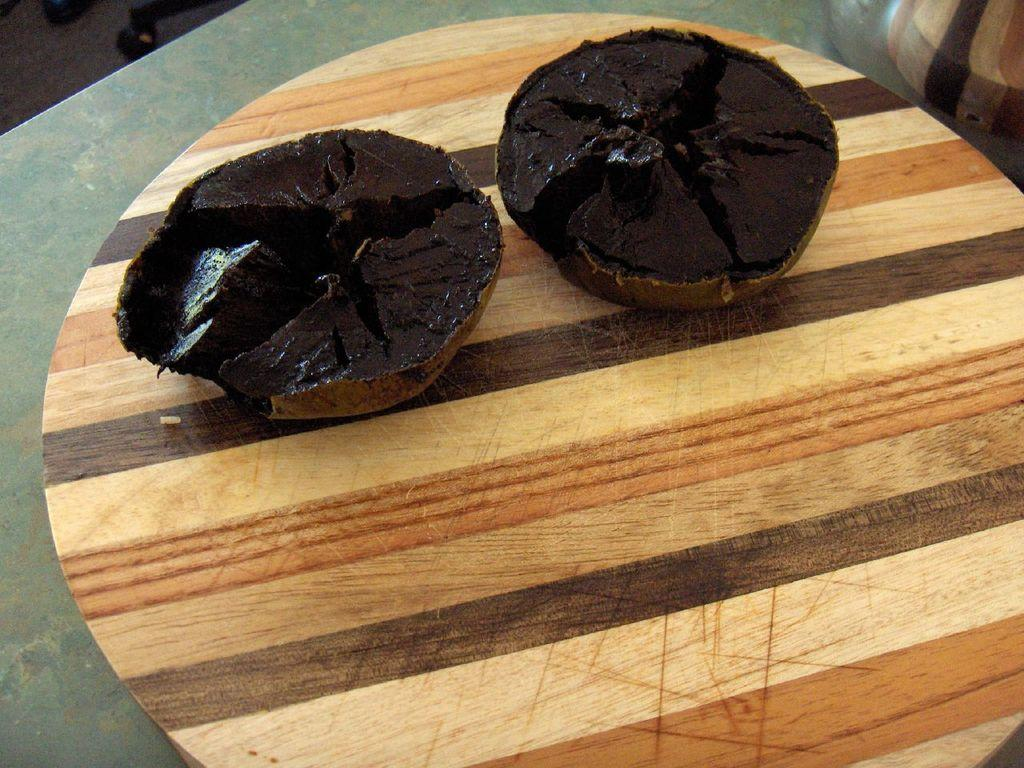What type of food is on the table in the image? There are muffins on the table in the image. What type of belief is represented by the muffins in the image? The muffins in the image do not represent any belief; they are simply a type of food. What type of lunch is being served with the muffins in the image? The image does not show any lunch being served; it only shows muffins on the table. 